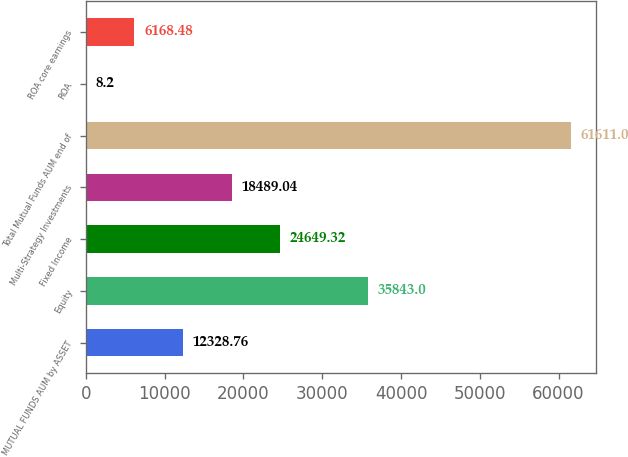Convert chart. <chart><loc_0><loc_0><loc_500><loc_500><bar_chart><fcel>MUTUAL FUNDS AUM by ASSET<fcel>Equity<fcel>Fixed Income<fcel>Multi-Strategy Investments<fcel>Total Mutual Funds AUM end of<fcel>ROA<fcel>ROA core earnings<nl><fcel>12328.8<fcel>35843<fcel>24649.3<fcel>18489<fcel>61611<fcel>8.2<fcel>6168.48<nl></chart> 